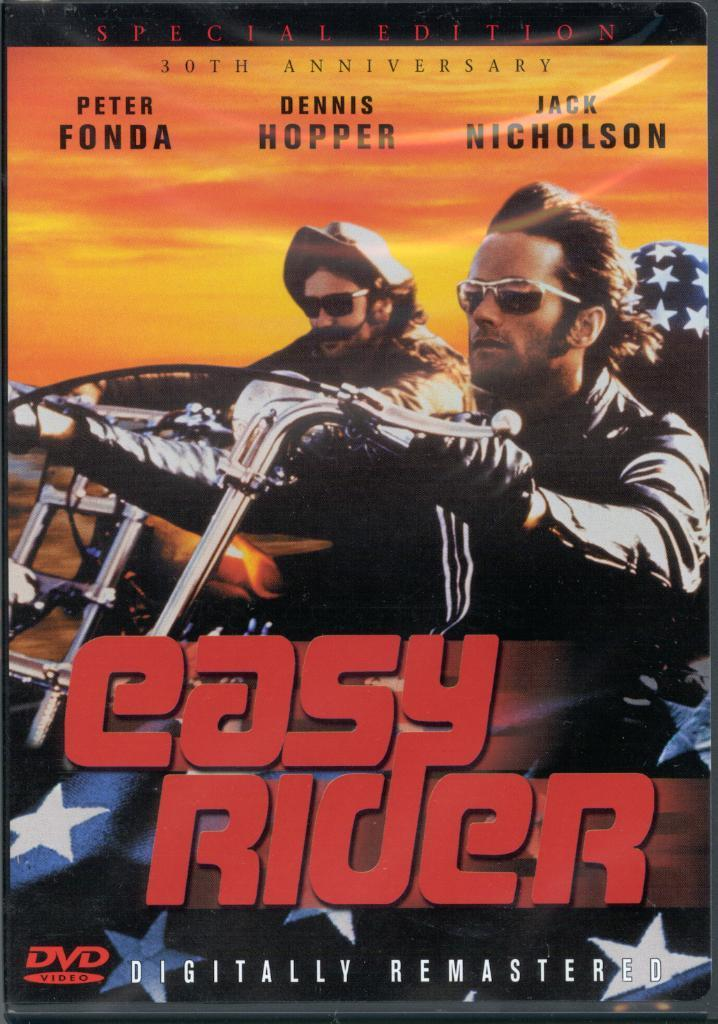<image>
Relay a brief, clear account of the picture shown. 30th anniversary special edition dvd for easy rider 